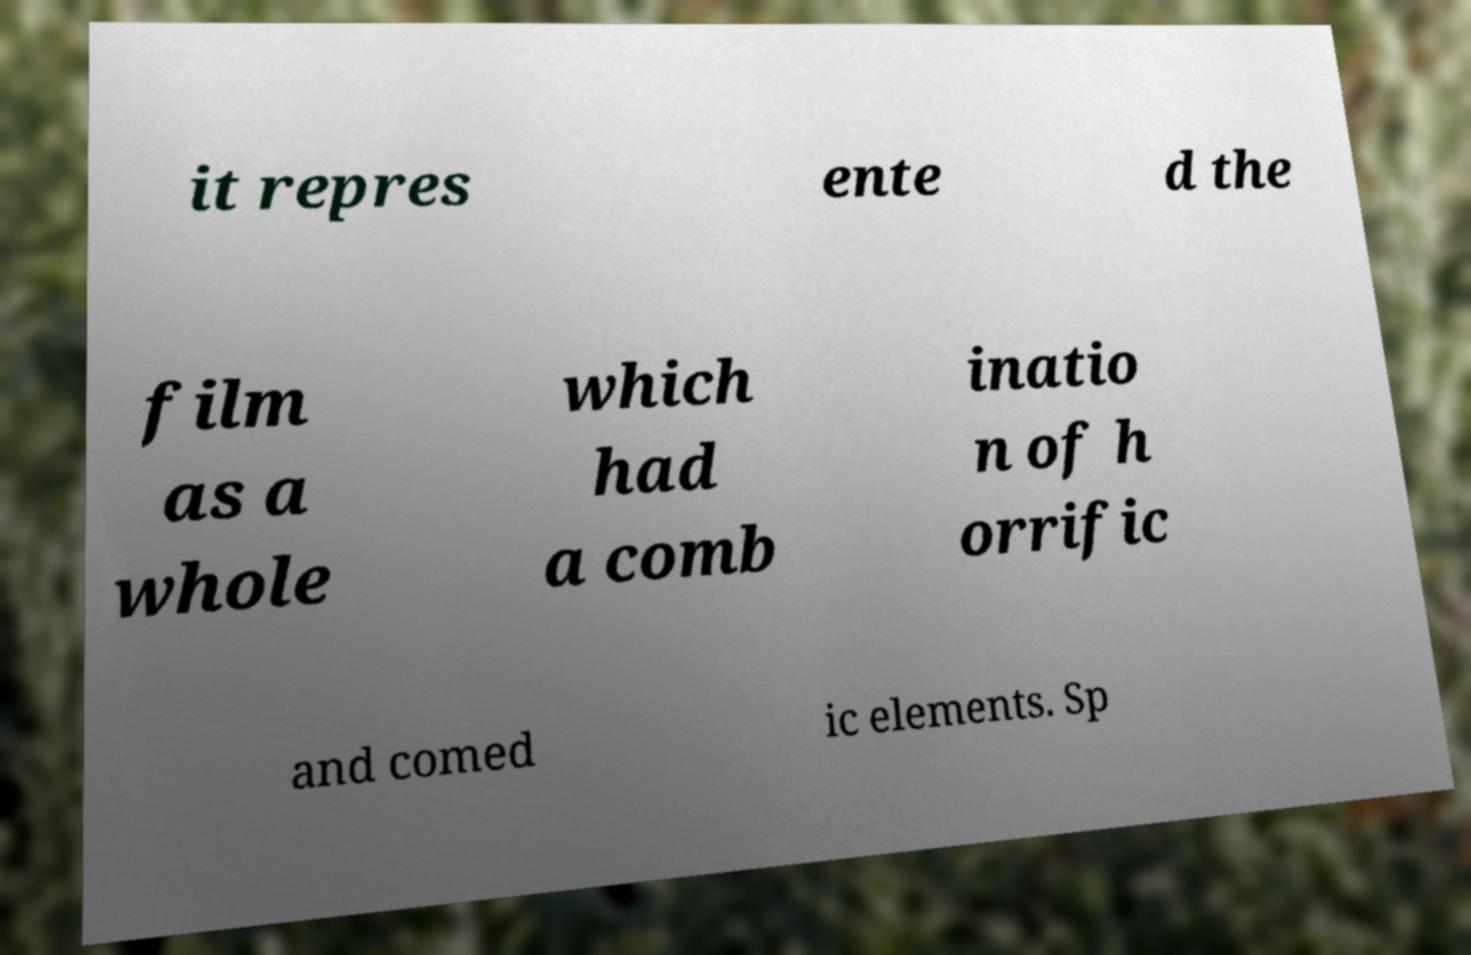Can you accurately transcribe the text from the provided image for me? it repres ente d the film as a whole which had a comb inatio n of h orrific and comed ic elements. Sp 